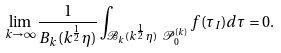<formula> <loc_0><loc_0><loc_500><loc_500>\lim _ { k \rightarrow \infty } \frac { 1 } { B _ { k } ( k ^ { \frac { 1 } { 2 } } \eta ) } \int _ { \mathcal { B } _ { k } ( k ^ { \frac { 1 } { 2 } } \eta ) \ \mathcal { P } _ { 0 } ^ { ( k ) } } f ( \tau _ { I } ) d \tau = 0 .</formula> 